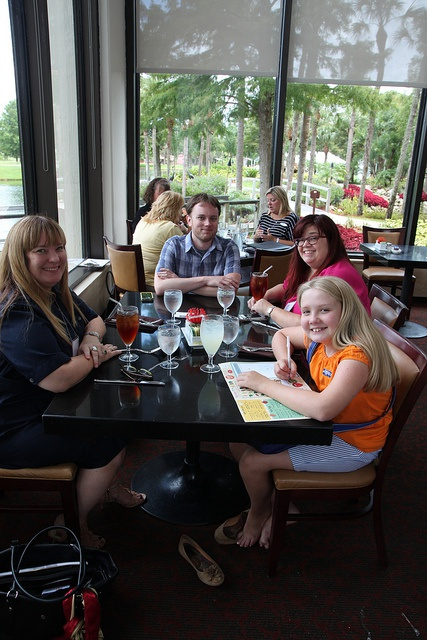Describe the objects in this image and their specific colors. I can see dining table in white, black, gray, lightgray, and darkgray tones, people in white, black, gray, and maroon tones, people in white, maroon, black, and gray tones, chair in white, black, maroon, gray, and darkgray tones, and handbag in white, black, gray, and blue tones in this image. 